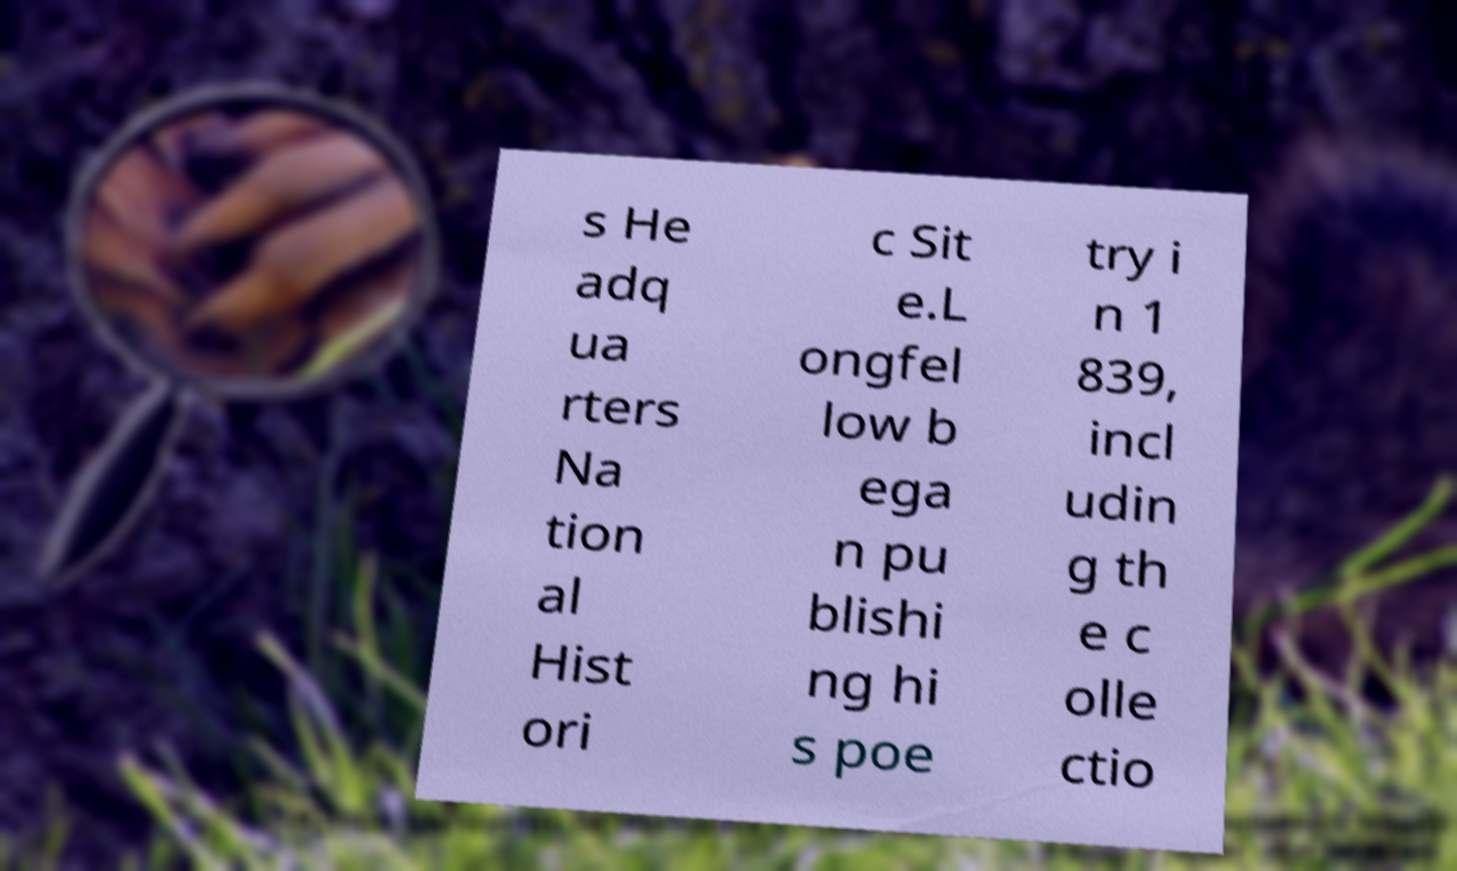Can you accurately transcribe the text from the provided image for me? s He adq ua rters Na tion al Hist ori c Sit e.L ongfel low b ega n pu blishi ng hi s poe try i n 1 839, incl udin g th e c olle ctio 